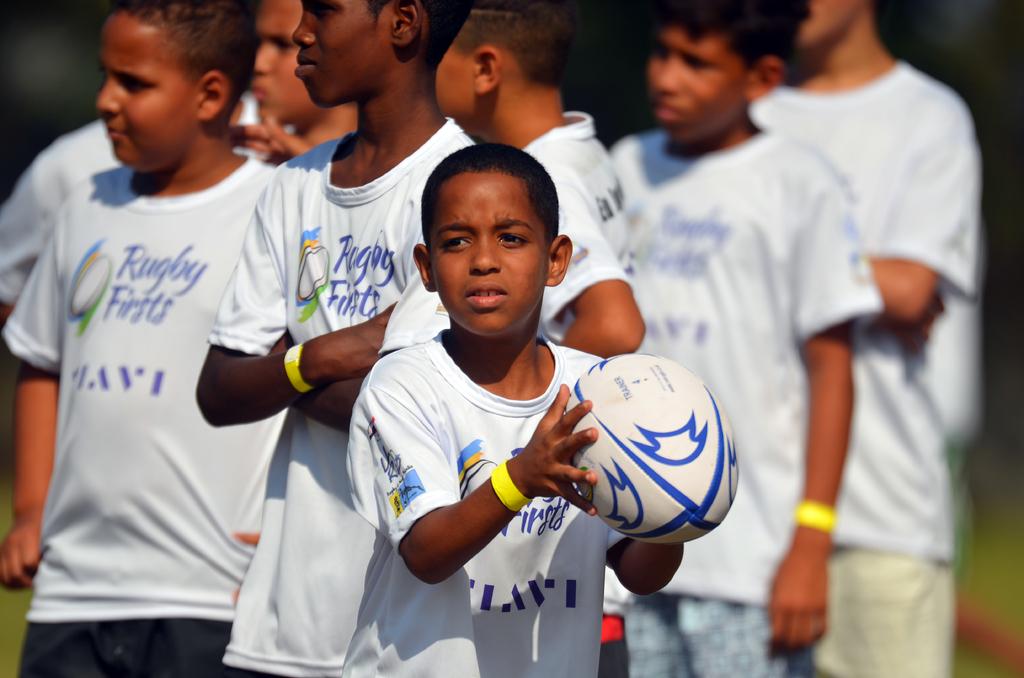What is the name of the team?
Offer a terse response. Rugby firsts. What is the name of the sport on the shirt?
Your answer should be very brief. Rugby. 